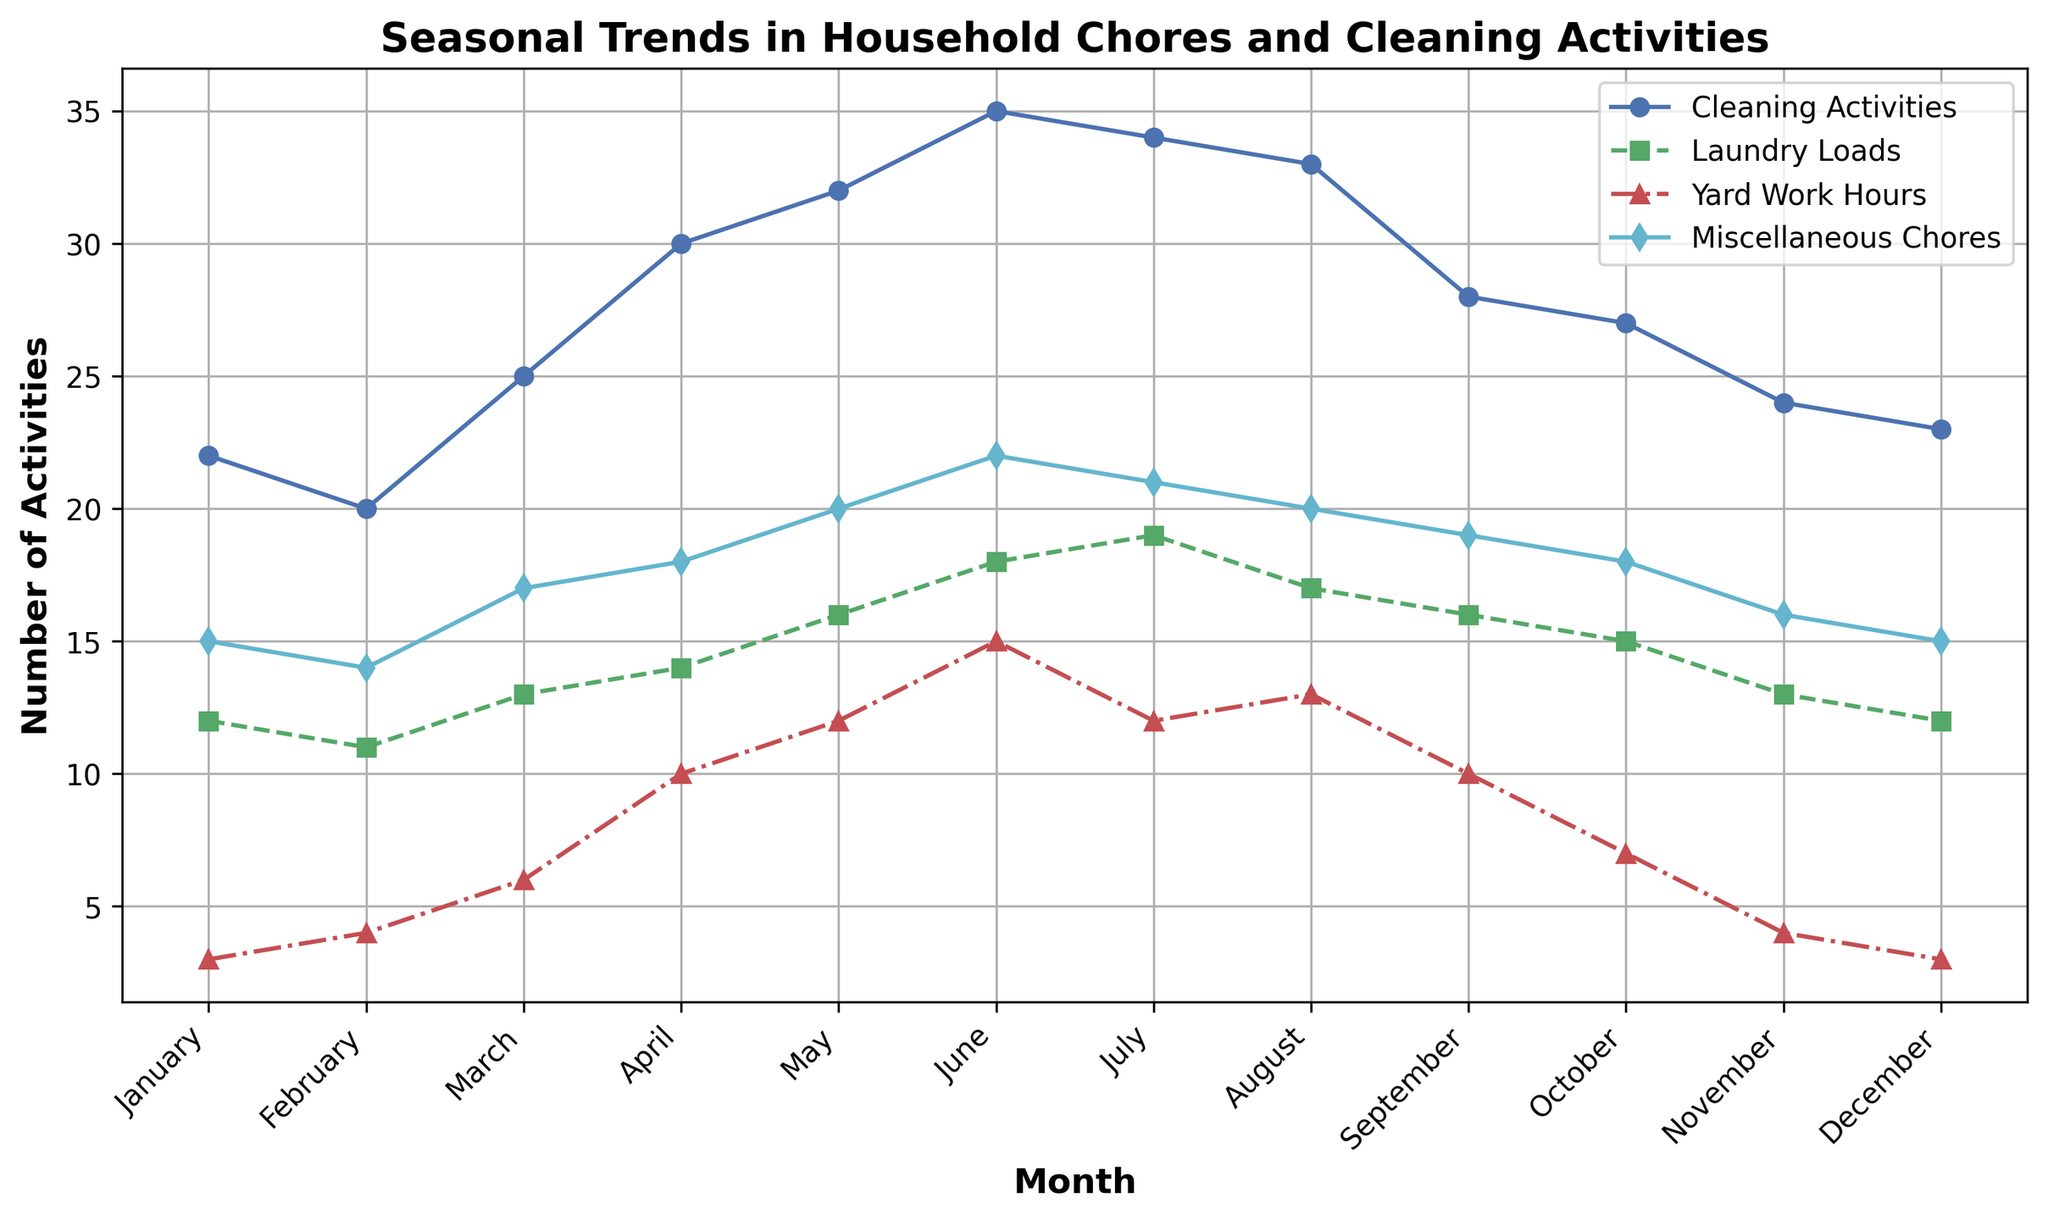What month has the highest number of laundry loads? February has 11 laundry loads. Every subsequent month shows a higher number until July, which peaks at 19 laundry loads. Thus, July has the highest number of laundry loads.
Answer: July Which month has the lowest number of yard work hours, and what is that number? Reviewing the yard work hours from each month, January and December each have the lowest values at 3 hours.
Answer: January, December In which month do cleaning activities peak, and how many activities are recorded? Checking the data, the number of cleaning activities peaks in June with 35 activities.
Answer: June, 35 How do the number of miscellaneous chores in April compare to those in November? The number of miscellaneous chores in April is 18, while in November it is 16. Therefore, April has more miscellaneous chores than November.
Answer: April has more What is the sum of laundry loads in the first and last month of the year? The number of laundry loads in January is 12, and in December it is also 12. Summing these values, 12 + 12 = 24.
Answer: 24 Compare the number of laundry loads in March and September. The number of laundry loads in March is 13, and in September it is 16. Therefore, September has more laundry loads than March.
Answer: September has more What trend can be observed in the number of yard work hours from January to July? The number of yard work hours increases steadily from January (3 hours) to July (12 hours), then decreases.
Answer: Increasing Which month has the most balanced distribution in the number of activities across all chore categories? Looking at the distribution of activities across months, May shows closely matched numbers: 32 cleaning activities, 16 laundry loads, 12 yard work hours, and 20 miscellaneous chores.
Answer: May Calculate the average number of miscellaneous chores for the first quarter of the year (January to March). The number of miscellaneous chores in the first quarter are January (15), February (14), and March (17). Summing these: 15 + 14 + 17 = 46. The average is 46/3 = 15.33.
Answer: 15.33 In which month do cleaning activities and laundry loads both peak, and what are their values? Cleaning activities peak in June with 35, and laundry loads peak in July with 19. Therefore, there isn't a single month where both peak simultaneously.
Answer: No single month 